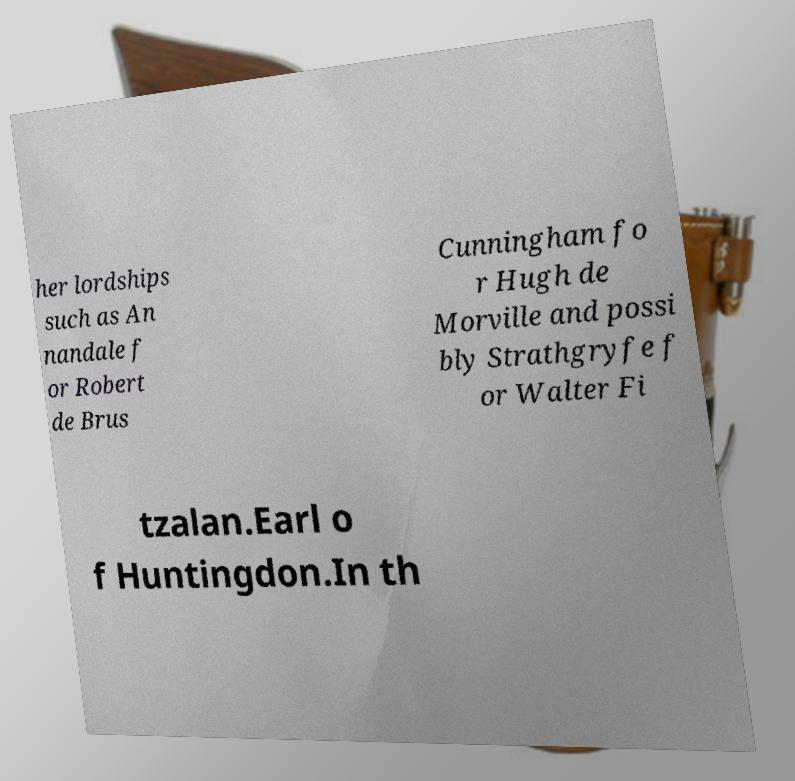Can you accurately transcribe the text from the provided image for me? her lordships such as An nandale f or Robert de Brus Cunningham fo r Hugh de Morville and possi bly Strathgryfe f or Walter Fi tzalan.Earl o f Huntingdon.In th 